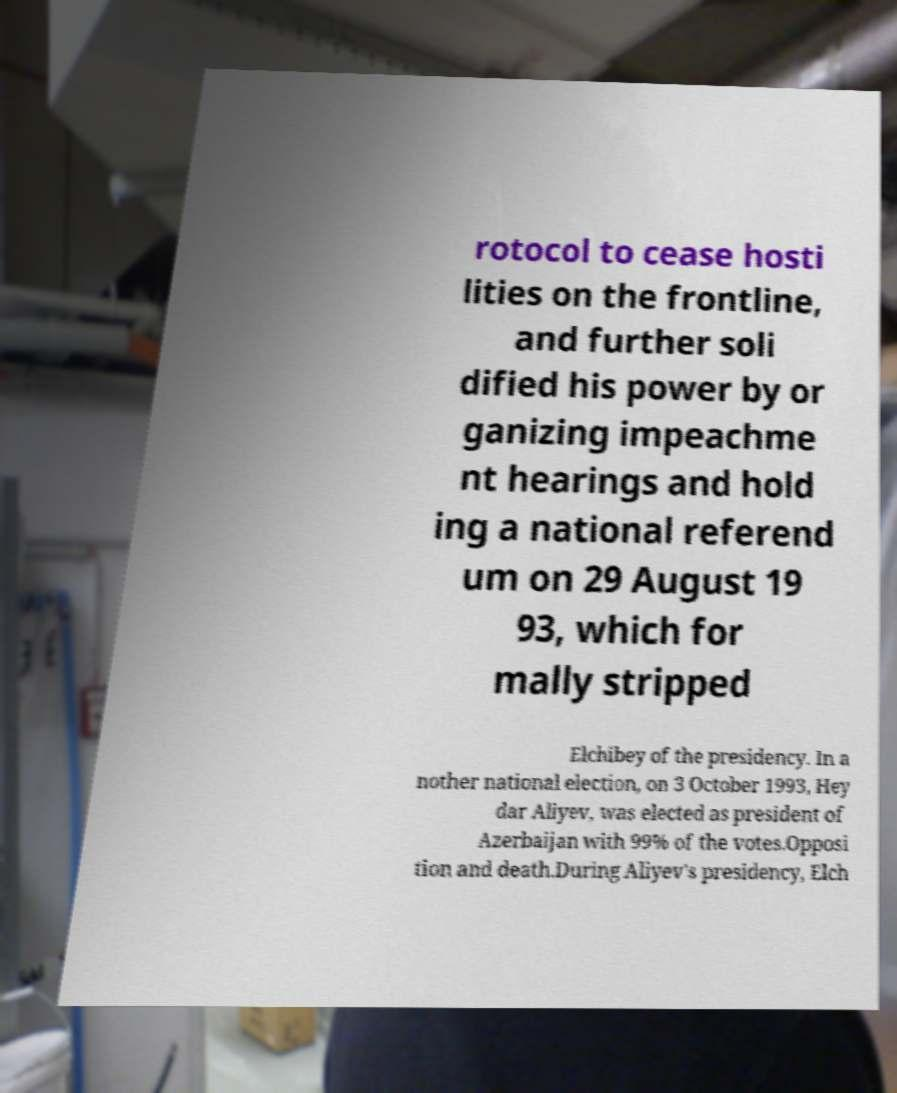Can you accurately transcribe the text from the provided image for me? rotocol to cease hosti lities on the frontline, and further soli dified his power by or ganizing impeachme nt hearings and hold ing a national referend um on 29 August 19 93, which for mally stripped Elchibey of the presidency. In a nother national election, on 3 October 1993, Hey dar Aliyev, was elected as president of Azerbaijan with 99% of the votes.Opposi tion and death.During Aliyev's presidency, Elch 